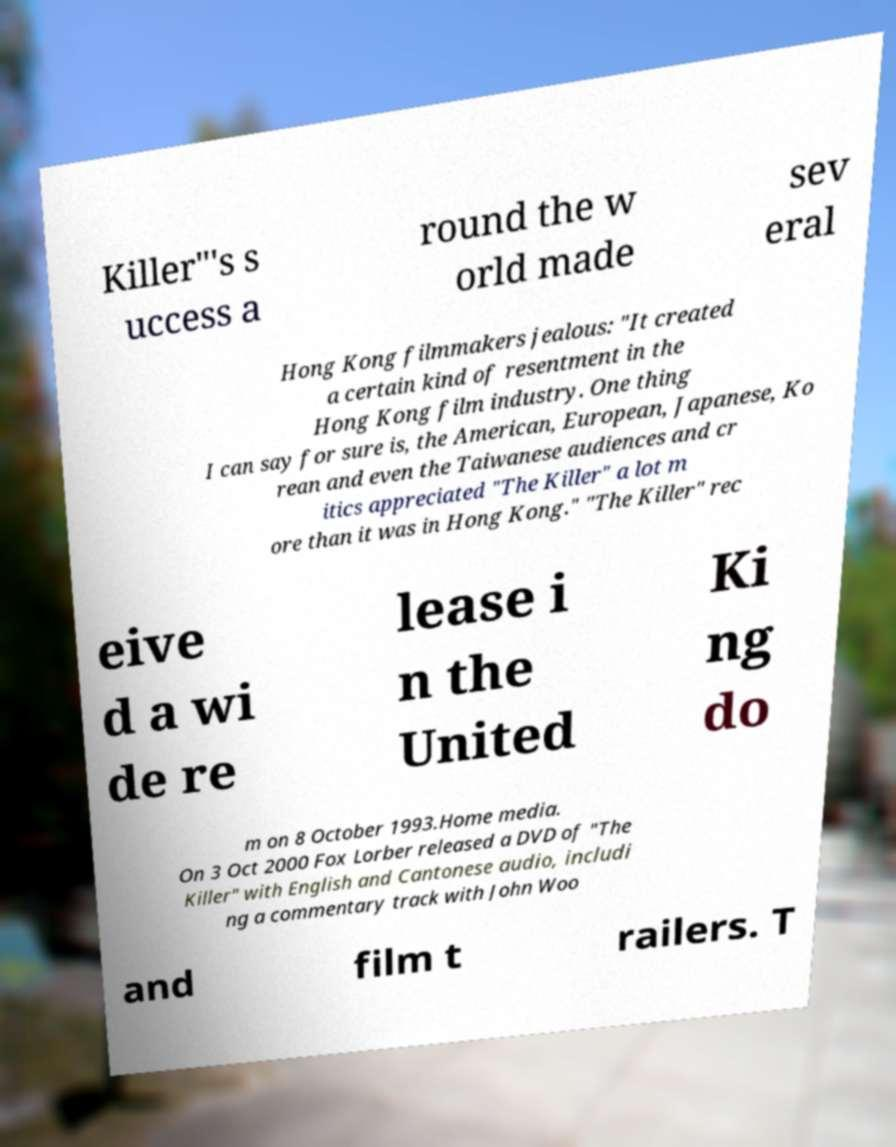For documentation purposes, I need the text within this image transcribed. Could you provide that? Killer"'s s uccess a round the w orld made sev eral Hong Kong filmmakers jealous: "It created a certain kind of resentment in the Hong Kong film industry. One thing I can say for sure is, the American, European, Japanese, Ko rean and even the Taiwanese audiences and cr itics appreciated "The Killer" a lot m ore than it was in Hong Kong." "The Killer" rec eive d a wi de re lease i n the United Ki ng do m on 8 October 1993.Home media. On 3 Oct 2000 Fox Lorber released a DVD of "The Killer" with English and Cantonese audio, includi ng a commentary track with John Woo and film t railers. T 